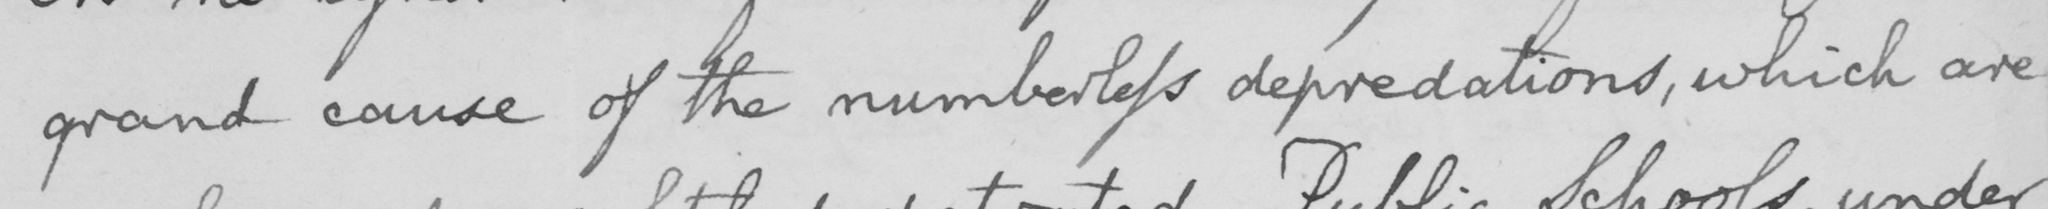Transcribe the text shown in this historical manuscript line. grand cause of the numberless depredations , which are 